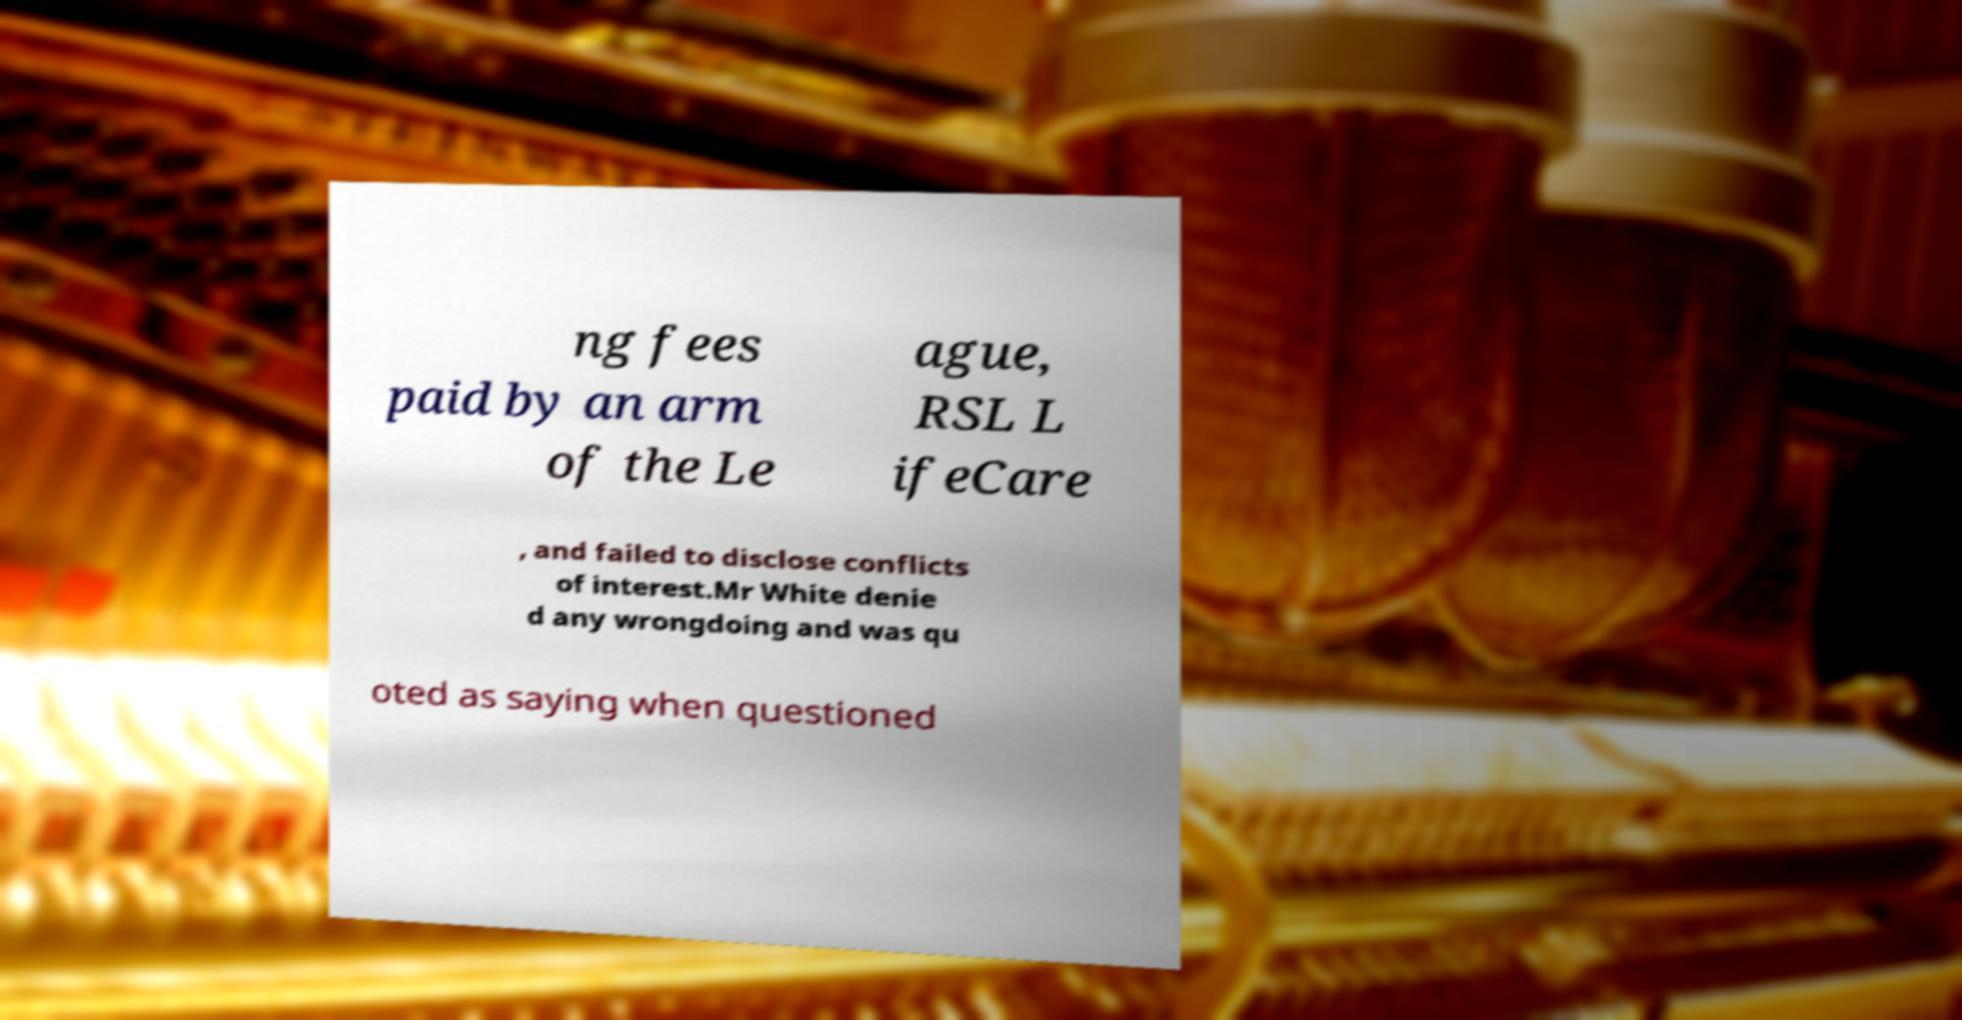Could you assist in decoding the text presented in this image and type it out clearly? ng fees paid by an arm of the Le ague, RSL L ifeCare , and failed to disclose conflicts of interest.Mr White denie d any wrongdoing and was qu oted as saying when questioned 